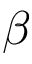Convert formula to latex. <formula><loc_0><loc_0><loc_500><loc_500>\beta</formula> 